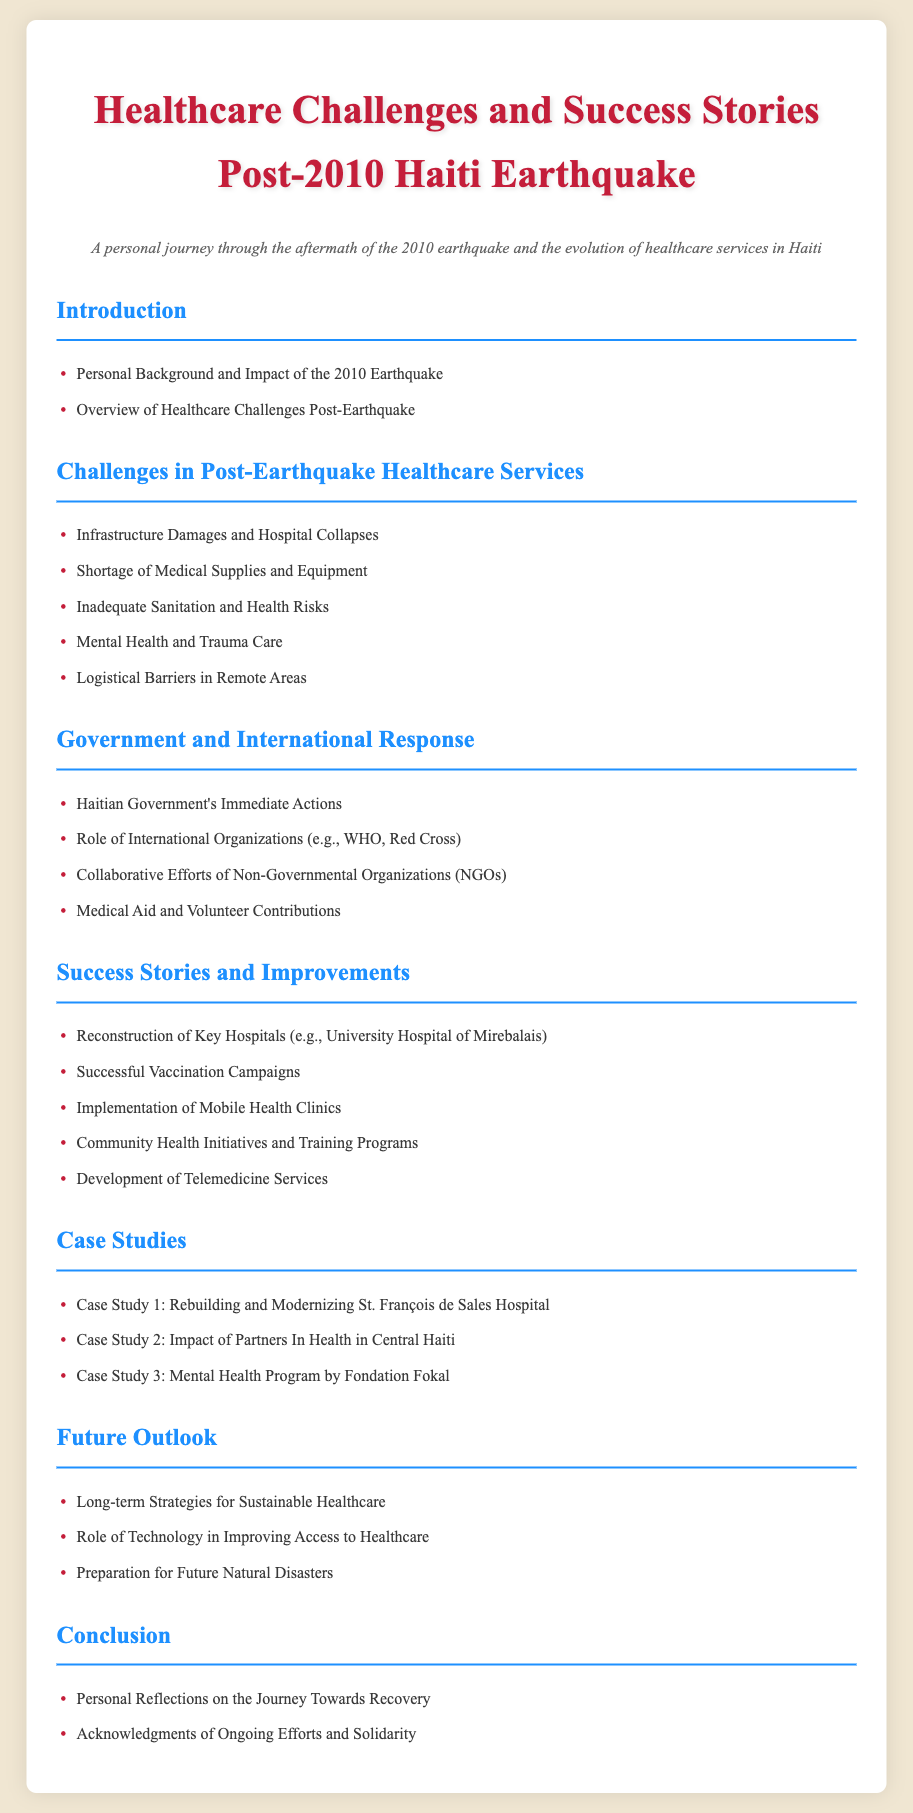what is the title of the document? The title of the document is clearly stated at the top, summarizing its focus on healthcare challenges and success stories related to the 2010 earthquake in Haiti.
Answer: Healthcare Challenges and Success Stories Post-2010 Haiti Earthquake how many challenges in post-earthquake healthcare services are listed? The document enumerates challenges under a specific section, which counts the bullet points provided.
Answer: Five which organization is mentioned in the Government and International Response section? One of the organizations listed that played a role in response efforts is the World Health Organization, a key player in healthcare emergencies.
Answer: WHO what type of health initiative is listed under Success Stories? The document mentions various improvement efforts in healthcare in Haiti, one of which is mobile health clinics, a significant initiative for access to care.
Answer: Mobile Health Clinics how many case studies are included in the document? The section dedicated to case studies states the number of specific examples being discussed, providing insight into successes achieved.
Answer: Three what is one of the long-term strategies mentioned for sustainable healthcare? The future outlook section discusses various strategies, and one of them focuses on creating sustainable healthcare systems in the aftermath of the earthquake.
Answer: Sustainable Healthcare which hospital is specifically mentioned in the success stories section? The success stories highlight the reconstruction of a significant facility, mentioning a specific hospital by name, showcasing improvements made after the earthquake.
Answer: University Hospital of Mirebalais what is emphasized in the conclusion section? The conclusion encapsulates personal perspectives and wider acknowledgment of recovery efforts, underlying the emotional and community aspects of the journey post-disaster.
Answer: Personal Reflections on the Journey Towards Recovery 